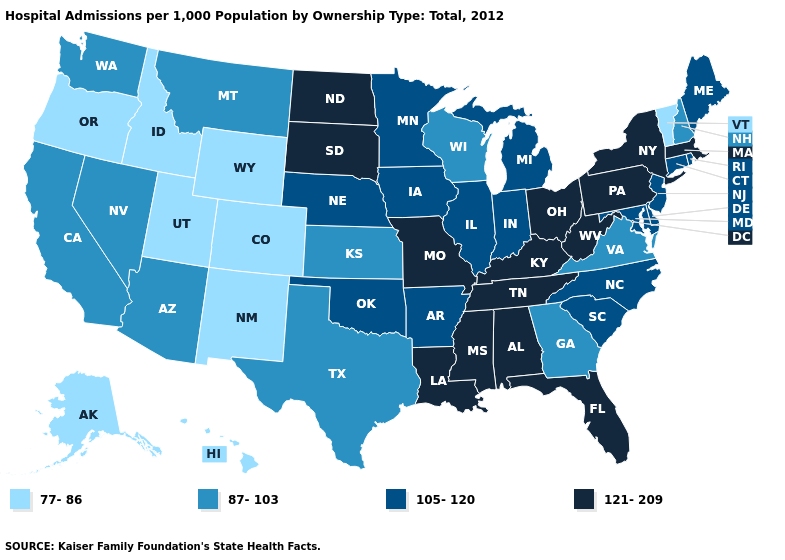What is the highest value in states that border Rhode Island?
Write a very short answer. 121-209. What is the value of Michigan?
Concise answer only. 105-120. Does New Mexico have a lower value than Vermont?
Give a very brief answer. No. How many symbols are there in the legend?
Keep it brief. 4. Does Indiana have a lower value than Nebraska?
Keep it brief. No. Which states have the highest value in the USA?
Be succinct. Alabama, Florida, Kentucky, Louisiana, Massachusetts, Mississippi, Missouri, New York, North Dakota, Ohio, Pennsylvania, South Dakota, Tennessee, West Virginia. Among the states that border Kansas , which have the lowest value?
Be succinct. Colorado. Name the states that have a value in the range 77-86?
Quick response, please. Alaska, Colorado, Hawaii, Idaho, New Mexico, Oregon, Utah, Vermont, Wyoming. Name the states that have a value in the range 77-86?
Short answer required. Alaska, Colorado, Hawaii, Idaho, New Mexico, Oregon, Utah, Vermont, Wyoming. Name the states that have a value in the range 121-209?
Write a very short answer. Alabama, Florida, Kentucky, Louisiana, Massachusetts, Mississippi, Missouri, New York, North Dakota, Ohio, Pennsylvania, South Dakota, Tennessee, West Virginia. Among the states that border California , which have the highest value?
Give a very brief answer. Arizona, Nevada. What is the lowest value in the MidWest?
Give a very brief answer. 87-103. Name the states that have a value in the range 77-86?
Concise answer only. Alaska, Colorado, Hawaii, Idaho, New Mexico, Oregon, Utah, Vermont, Wyoming. Does the map have missing data?
Short answer required. No. Which states have the lowest value in the USA?
Write a very short answer. Alaska, Colorado, Hawaii, Idaho, New Mexico, Oregon, Utah, Vermont, Wyoming. 